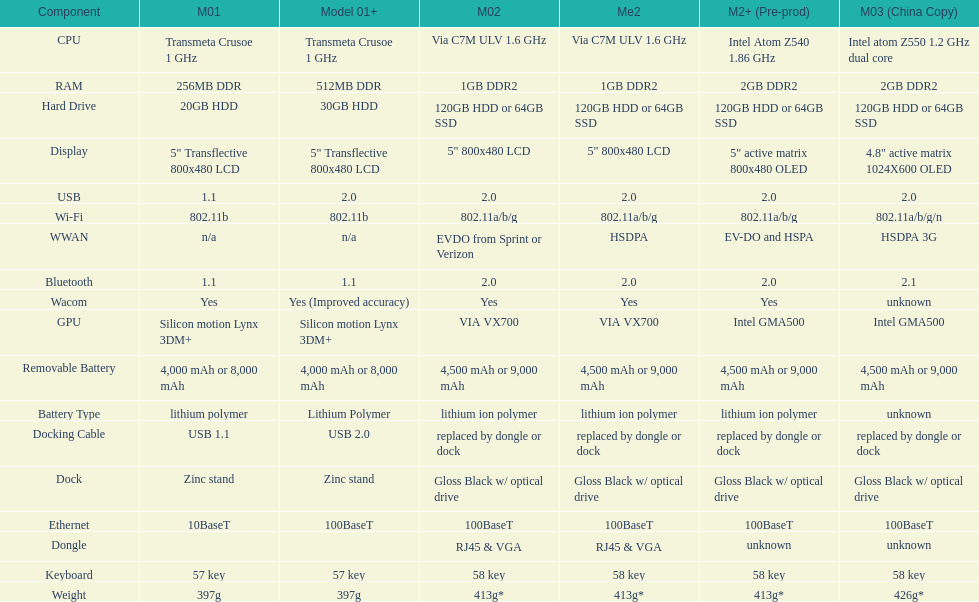Which model provides a larger hard drive: model 01 or model 02? Model 02. 